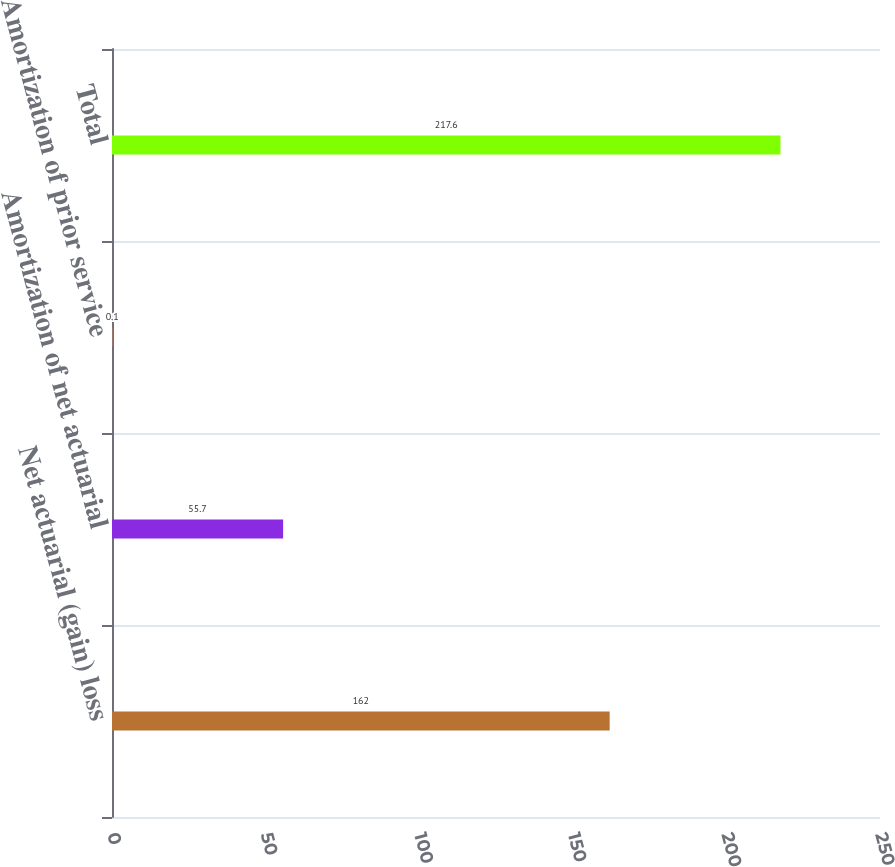Convert chart. <chart><loc_0><loc_0><loc_500><loc_500><bar_chart><fcel>Net actuarial (gain) loss<fcel>Amortization of net actuarial<fcel>Amortization of prior service<fcel>Total<nl><fcel>162<fcel>55.7<fcel>0.1<fcel>217.6<nl></chart> 